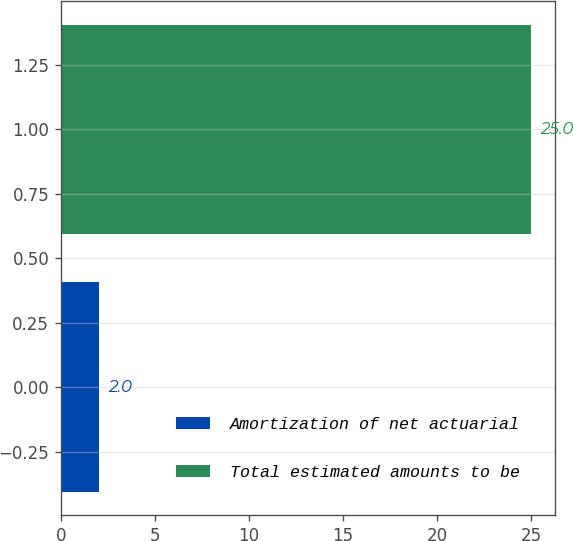Convert chart to OTSL. <chart><loc_0><loc_0><loc_500><loc_500><bar_chart><fcel>Amortization of net actuarial<fcel>Total estimated amounts to be<nl><fcel>2<fcel>25<nl></chart> 